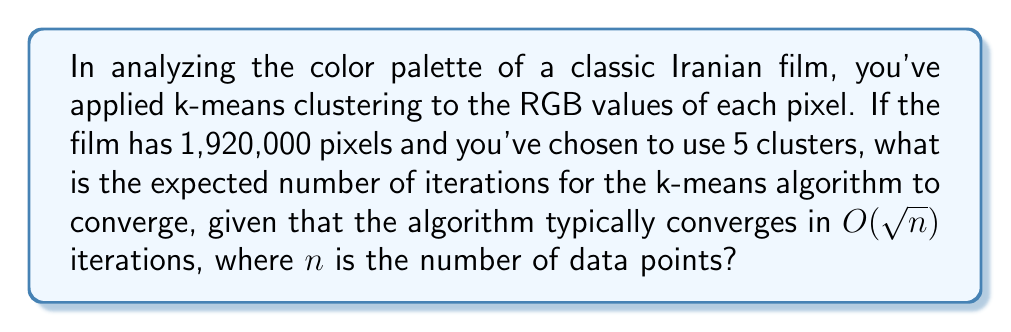What is the answer to this math problem? To solve this problem, we'll follow these steps:

1) First, we need to identify the number of data points ($n$) in our dataset. In this case, each pixel represents a data point, so:
   $n = 1,920,000$

2) The k-means algorithm typically converges in $O(\sqrt{n})$ iterations. This means the number of iterations is proportional to the square root of the number of data points.

3) To get an estimate of the actual number of iterations, we can simply calculate $\sqrt{n}$:

   $$\sqrt{n} = \sqrt{1,920,000} = 1,385.64$$

4) Since we can't have a fractional number of iterations, we round this up to the nearest whole number:

   $$\lceil\sqrt{1,920,000}\rceil = 1,386$$

Therefore, we expect the k-means algorithm to converge in approximately 1,386 iterations for this dataset.

Note: The actual number of iterations may vary due to factors such as the initial placement of centroids and the specific characteristics of the data. This calculation provides an expected order of magnitude based on the asymptotic behavior of the algorithm.
Answer: 1,386 iterations 